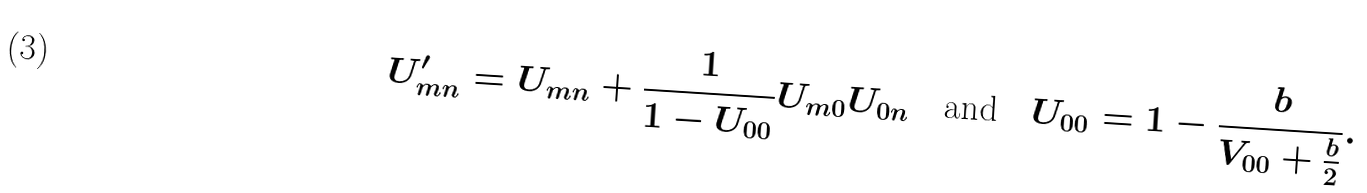<formula> <loc_0><loc_0><loc_500><loc_500>U ^ { \prime } _ { m n } = U _ { m n } + \frac { 1 } { 1 - U _ { 0 0 } } U _ { m 0 } U _ { 0 n } \quad \text {and} \quad U _ { 0 0 } = 1 - \frac { b } { V _ { 0 0 } + \frac { b } { 2 } } .</formula> 